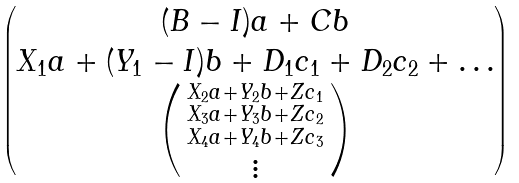<formula> <loc_0><loc_0><loc_500><loc_500>\begin{pmatrix} ( B - I ) a + C b \\ X _ { 1 } a + ( Y _ { 1 } - I ) b + D _ { 1 } c _ { 1 } + D _ { 2 } c _ { 2 } + \dots \\ \left ( \begin{smallmatrix} X _ { 2 } a + Y _ { 2 } b + Z c _ { 1 } \\ X _ { 3 } a + Y _ { 3 } b + Z c _ { 2 } \\ X _ { 4 } a + Y _ { 4 } b + Z c _ { 3 } \\ \vdots \end{smallmatrix} \right ) \end{pmatrix}</formula> 